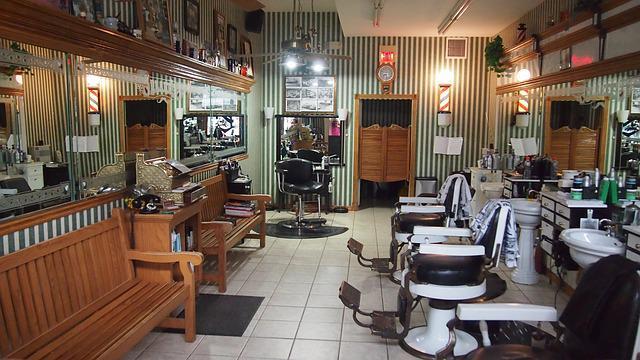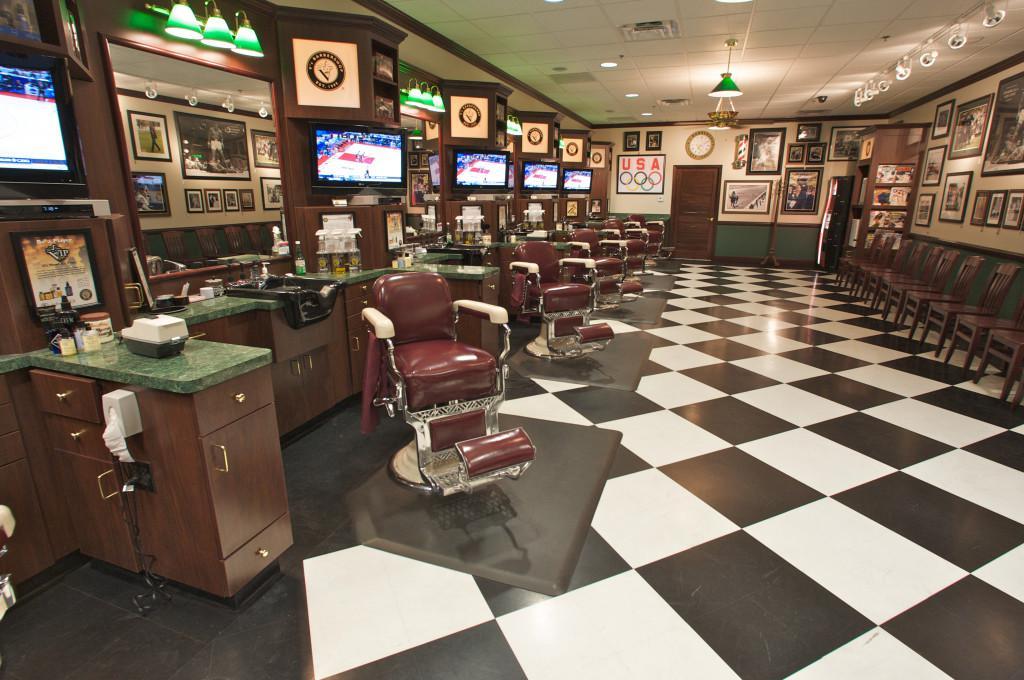The first image is the image on the left, the second image is the image on the right. Evaluate the accuracy of this statement regarding the images: "There is exactly one television screen in the image on the right.". Is it true? Answer yes or no. No. The first image is the image on the left, the second image is the image on the right. Analyze the images presented: Is the assertion "The image on the right contains at least one person." valid? Answer yes or no. No. 